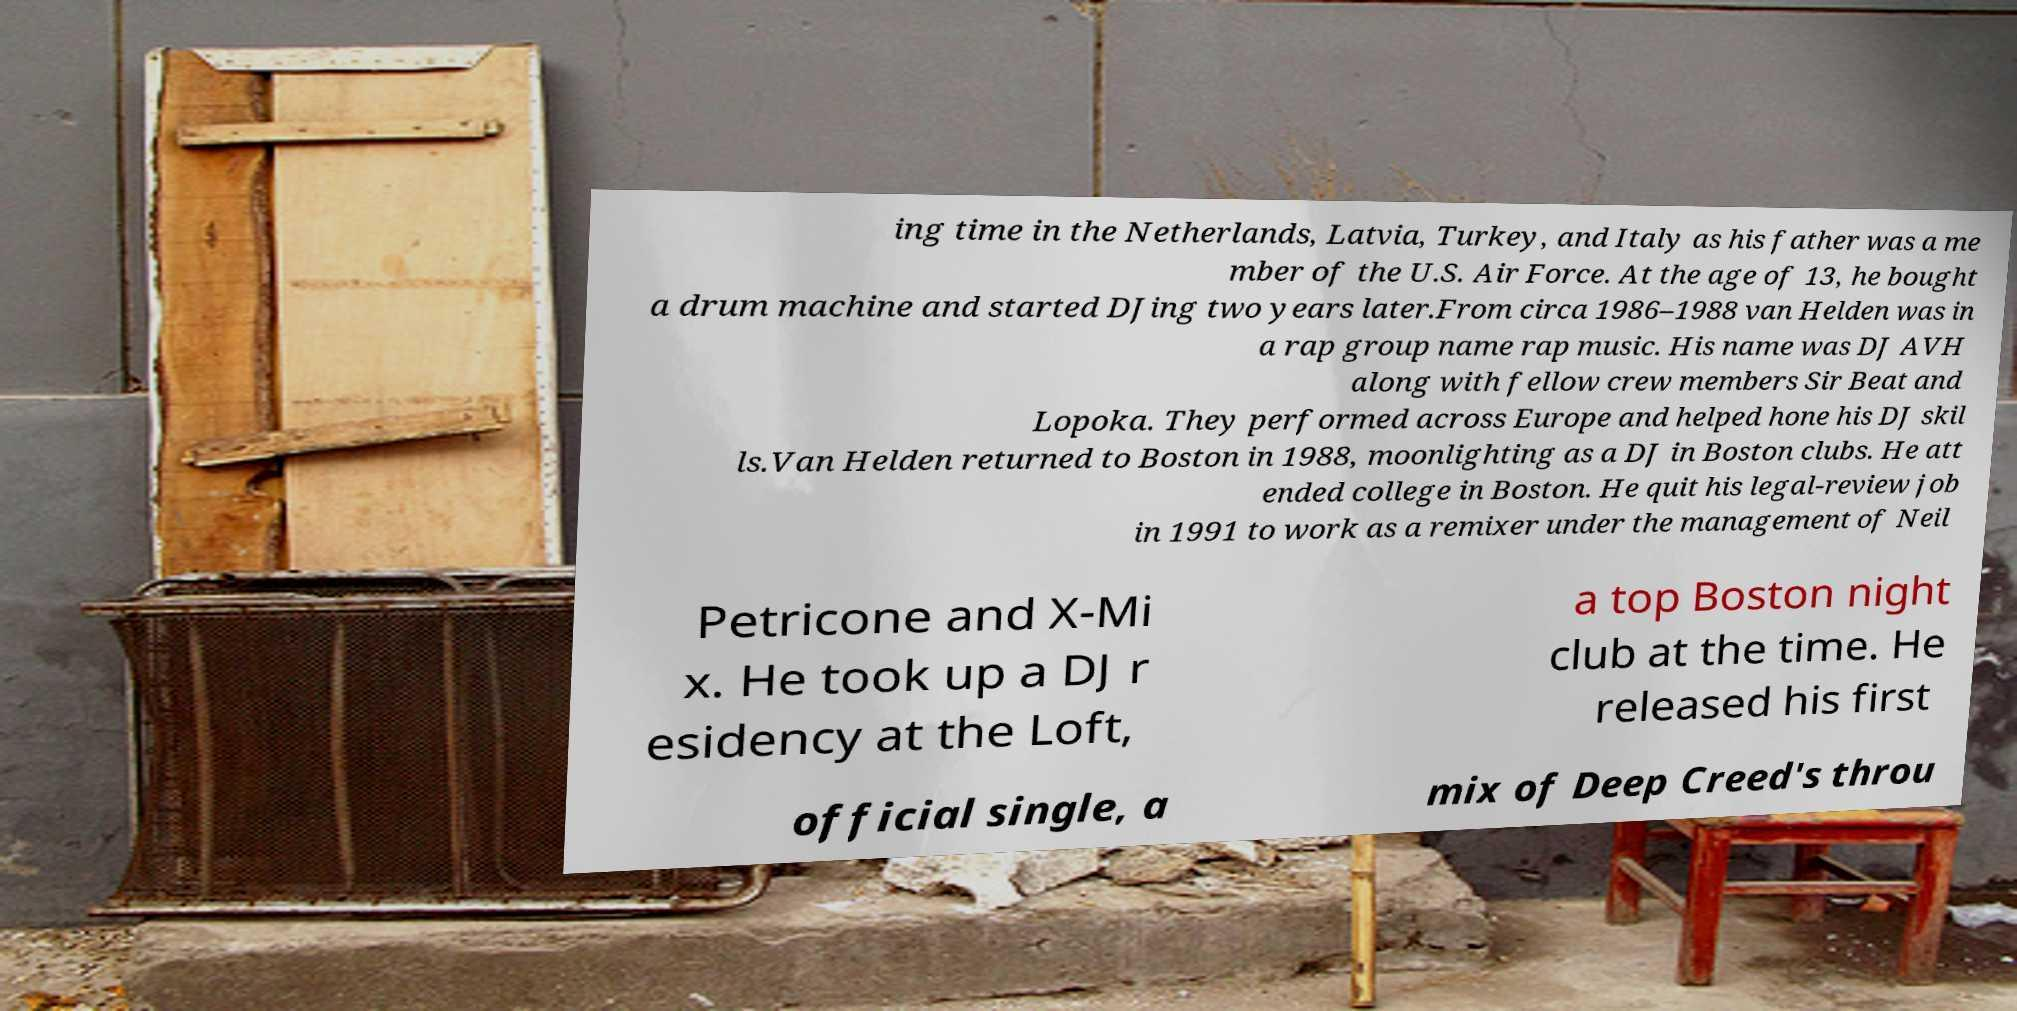Could you extract and type out the text from this image? ing time in the Netherlands, Latvia, Turkey, and Italy as his father was a me mber of the U.S. Air Force. At the age of 13, he bought a drum machine and started DJing two years later.From circa 1986–1988 van Helden was in a rap group name rap music. His name was DJ AVH along with fellow crew members Sir Beat and Lopoka. They performed across Europe and helped hone his DJ skil ls.Van Helden returned to Boston in 1988, moonlighting as a DJ in Boston clubs. He att ended college in Boston. He quit his legal-review job in 1991 to work as a remixer under the management of Neil Petricone and X-Mi x. He took up a DJ r esidency at the Loft, a top Boston night club at the time. He released his first official single, a mix of Deep Creed's throu 